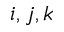Convert formula to latex. <formula><loc_0><loc_0><loc_500><loc_500>i , j , k</formula> 